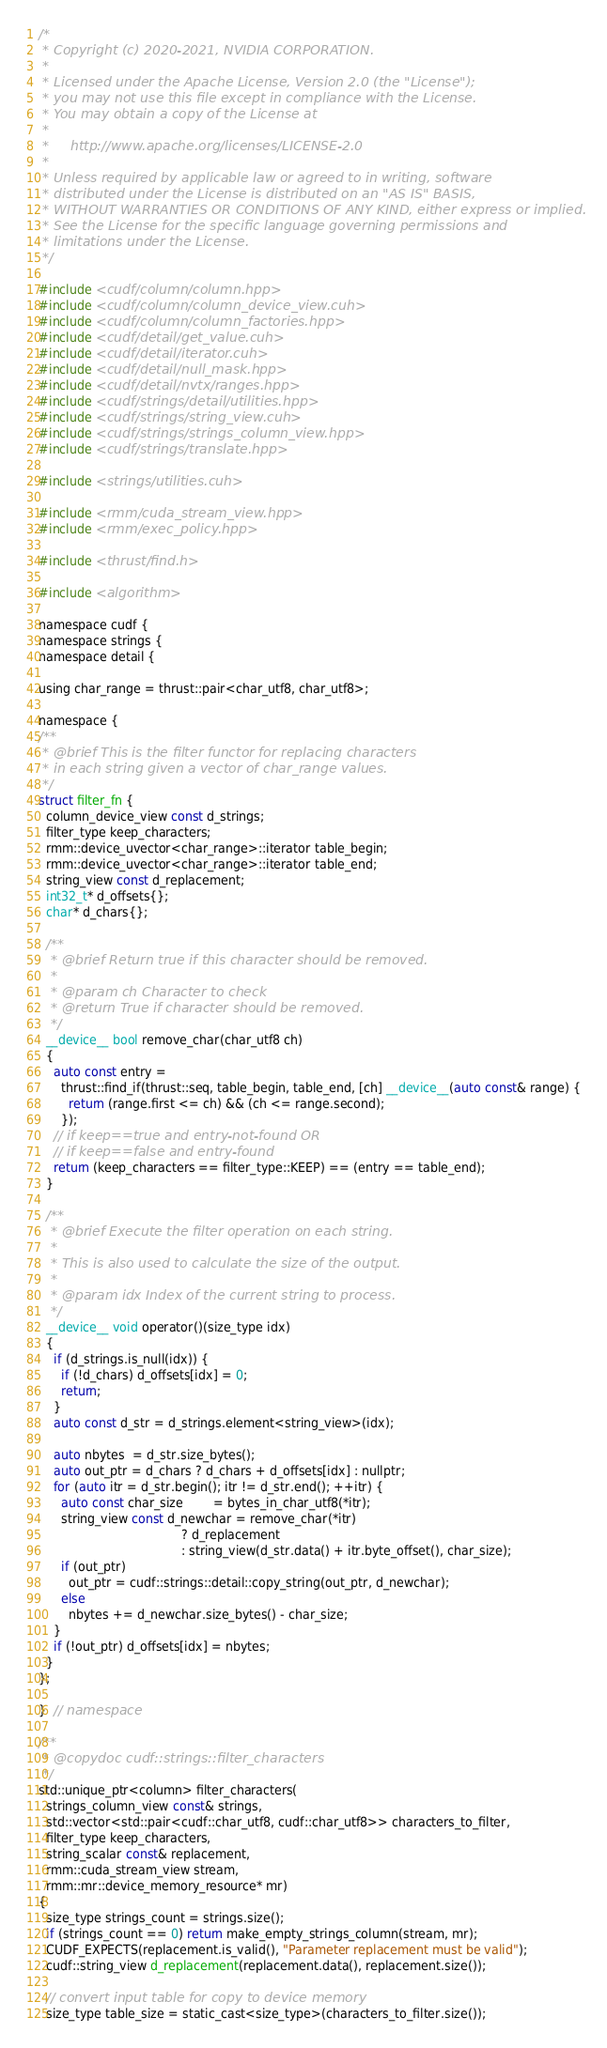<code> <loc_0><loc_0><loc_500><loc_500><_Cuda_>/*
 * Copyright (c) 2020-2021, NVIDIA CORPORATION.
 *
 * Licensed under the Apache License, Version 2.0 (the "License");
 * you may not use this file except in compliance with the License.
 * You may obtain a copy of the License at
 *
 *     http://www.apache.org/licenses/LICENSE-2.0
 *
 * Unless required by applicable law or agreed to in writing, software
 * distributed under the License is distributed on an "AS IS" BASIS,
 * WITHOUT WARRANTIES OR CONDITIONS OF ANY KIND, either express or implied.
 * See the License for the specific language governing permissions and
 * limitations under the License.
 */

#include <cudf/column/column.hpp>
#include <cudf/column/column_device_view.cuh>
#include <cudf/column/column_factories.hpp>
#include <cudf/detail/get_value.cuh>
#include <cudf/detail/iterator.cuh>
#include <cudf/detail/null_mask.hpp>
#include <cudf/detail/nvtx/ranges.hpp>
#include <cudf/strings/detail/utilities.hpp>
#include <cudf/strings/string_view.cuh>
#include <cudf/strings/strings_column_view.hpp>
#include <cudf/strings/translate.hpp>

#include <strings/utilities.cuh>

#include <rmm/cuda_stream_view.hpp>
#include <rmm/exec_policy.hpp>

#include <thrust/find.h>

#include <algorithm>

namespace cudf {
namespace strings {
namespace detail {

using char_range = thrust::pair<char_utf8, char_utf8>;

namespace {
/**
 * @brief This is the filter functor for replacing characters
 * in each string given a vector of char_range values.
 */
struct filter_fn {
  column_device_view const d_strings;
  filter_type keep_characters;
  rmm::device_uvector<char_range>::iterator table_begin;
  rmm::device_uvector<char_range>::iterator table_end;
  string_view const d_replacement;
  int32_t* d_offsets{};
  char* d_chars{};

  /**
   * @brief Return true if this character should be removed.
   *
   * @param ch Character to check
   * @return True if character should be removed.
   */
  __device__ bool remove_char(char_utf8 ch)
  {
    auto const entry =
      thrust::find_if(thrust::seq, table_begin, table_end, [ch] __device__(auto const& range) {
        return (range.first <= ch) && (ch <= range.second);
      });
    // if keep==true and entry-not-found OR
    // if keep==false and entry-found
    return (keep_characters == filter_type::KEEP) == (entry == table_end);
  }

  /**
   * @brief Execute the filter operation on each string.
   *
   * This is also used to calculate the size of the output.
   *
   * @param idx Index of the current string to process.
   */
  __device__ void operator()(size_type idx)
  {
    if (d_strings.is_null(idx)) {
      if (!d_chars) d_offsets[idx] = 0;
      return;
    }
    auto const d_str = d_strings.element<string_view>(idx);

    auto nbytes  = d_str.size_bytes();
    auto out_ptr = d_chars ? d_chars + d_offsets[idx] : nullptr;
    for (auto itr = d_str.begin(); itr != d_str.end(); ++itr) {
      auto const char_size        = bytes_in_char_utf8(*itr);
      string_view const d_newchar = remove_char(*itr)
                                      ? d_replacement
                                      : string_view(d_str.data() + itr.byte_offset(), char_size);
      if (out_ptr)
        out_ptr = cudf::strings::detail::copy_string(out_ptr, d_newchar);
      else
        nbytes += d_newchar.size_bytes() - char_size;
    }
    if (!out_ptr) d_offsets[idx] = nbytes;
  }
};

}  // namespace

/**
 * @copydoc cudf::strings::filter_characters
 */
std::unique_ptr<column> filter_characters(
  strings_column_view const& strings,
  std::vector<std::pair<cudf::char_utf8, cudf::char_utf8>> characters_to_filter,
  filter_type keep_characters,
  string_scalar const& replacement,
  rmm::cuda_stream_view stream,
  rmm::mr::device_memory_resource* mr)
{
  size_type strings_count = strings.size();
  if (strings_count == 0) return make_empty_strings_column(stream, mr);
  CUDF_EXPECTS(replacement.is_valid(), "Parameter replacement must be valid");
  cudf::string_view d_replacement(replacement.data(), replacement.size());

  // convert input table for copy to device memory
  size_type table_size = static_cast<size_type>(characters_to_filter.size());</code> 